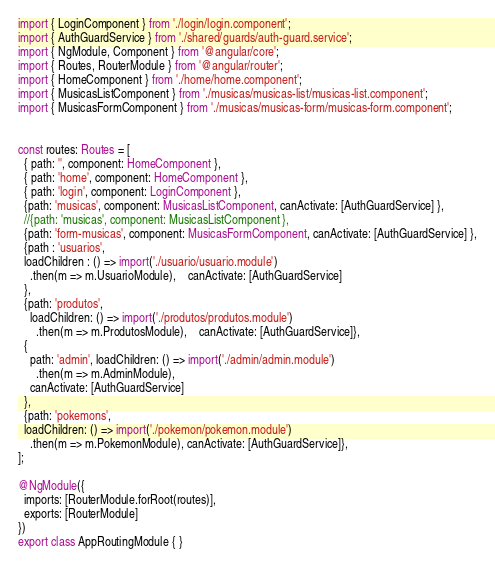Convert code to text. <code><loc_0><loc_0><loc_500><loc_500><_TypeScript_>import { LoginComponent } from './login/login.component';
import { AuthGuardService } from './shared/guards/auth-guard.service';
import { NgModule, Component } from '@angular/core';
import { Routes, RouterModule } from '@angular/router';
import { HomeComponent } from './home/home.component';
import { MusicasListComponent } from './musicas/musicas-list/musicas-list.component';
import { MusicasFormComponent } from './musicas/musicas-form/musicas-form.component';


const routes: Routes = [
  { path: '', component: HomeComponent },
  { path: 'home', component: HomeComponent },
  { path: 'login', component: LoginComponent },
  {path: 'musicas', component: MusicasListComponent, canActivate: [AuthGuardService] },
  //{path: 'musicas', component: MusicasListComponent },
  {path: 'form-musicas', component: MusicasFormComponent, canActivate: [AuthGuardService] },
  {path : 'usuarios',
  loadChildren : () => import('./usuario/usuario.module')
    .then(m => m.UsuarioModule),    canActivate: [AuthGuardService]
  },
  {path: 'produtos',
    loadChildren: () => import('./produtos/produtos.module')
      .then(m => m.ProdutosModule),    canActivate: [AuthGuardService]},
  {
    path: 'admin', loadChildren: () => import('./admin/admin.module')
      .then(m => m.AdminModule),
    canActivate: [AuthGuardService]
  },
  {path: 'pokemons',
  loadChildren: () => import('./pokemon/pokemon.module')
    .then(m => m.PokemonModule), canActivate: [AuthGuardService]},
];

@NgModule({
  imports: [RouterModule.forRoot(routes)],
  exports: [RouterModule]
})
export class AppRoutingModule { }
</code> 